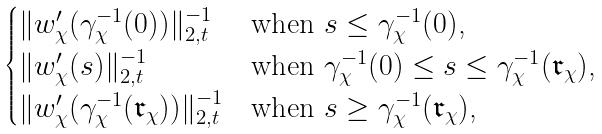Convert formula to latex. <formula><loc_0><loc_0><loc_500><loc_500>\begin{cases} \| w ^ { \prime } _ { \chi } ( \gamma _ { \chi } ^ { - 1 } ( 0 ) ) \| _ { 2 , t } ^ { - 1 } & \text {when $s\leq \gamma_{\chi}^{-1}(0)$,} \\ \| w ^ { \prime } _ { \chi } ( s ) \| _ { 2 , t } ^ { - 1 } & \text {when $\gamma_{\chi}^{-1}(0)\leq s\leq \gamma_{\chi}^{-1}(\mathfrak{r}_{\chi})$,} \\ \| w ^ { \prime } _ { \chi } ( \gamma _ { \chi } ^ { - 1 } ( \mathfrak { r } _ { \chi } ) ) \| _ { 2 , t } ^ { - 1 } & \text {when $s\geq\gamma_{\chi}^{-1}(\mathfrak{r}_{\chi})$,} \end{cases}</formula> 